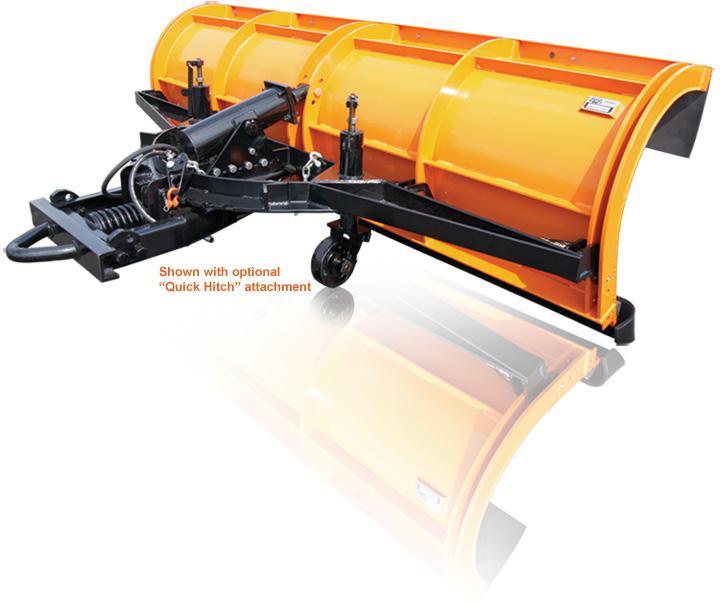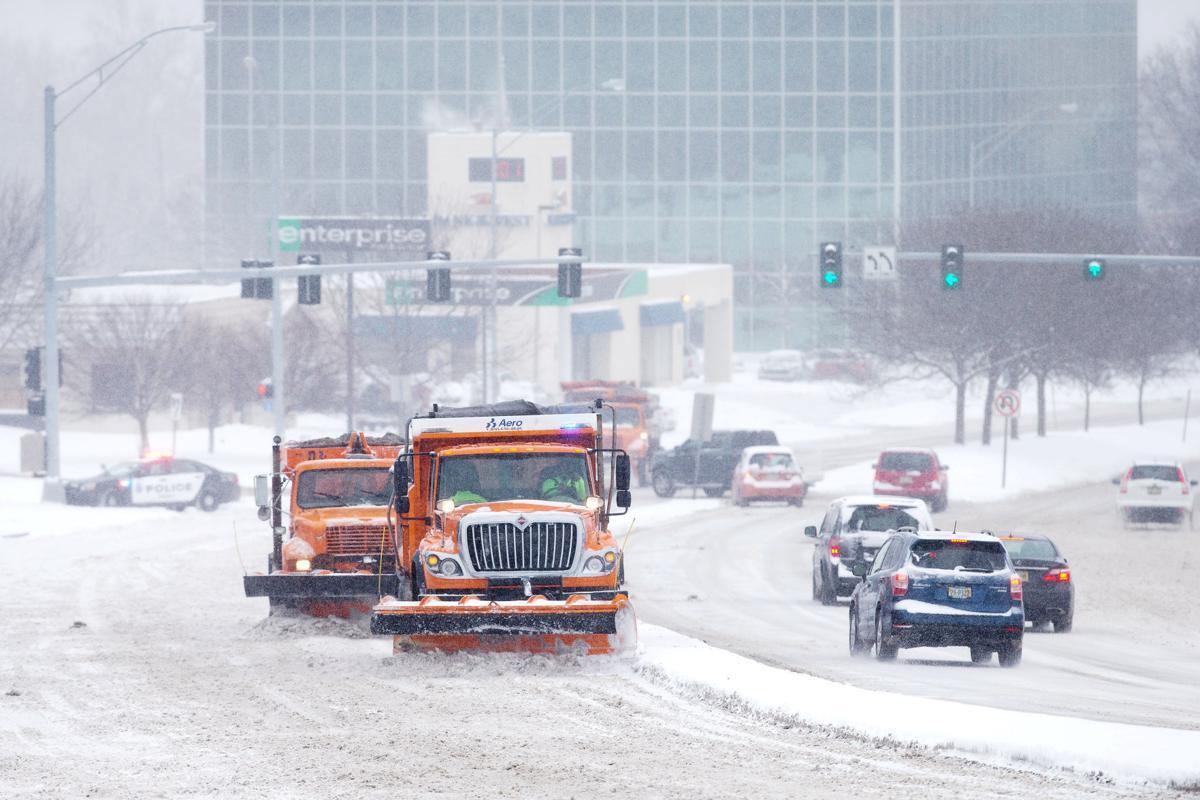The first image is the image on the left, the second image is the image on the right. Evaluate the accuracy of this statement regarding the images: "The left image shows an unattached yellow snow plow with its back side facing the camera.". Is it true? Answer yes or no. Yes. 